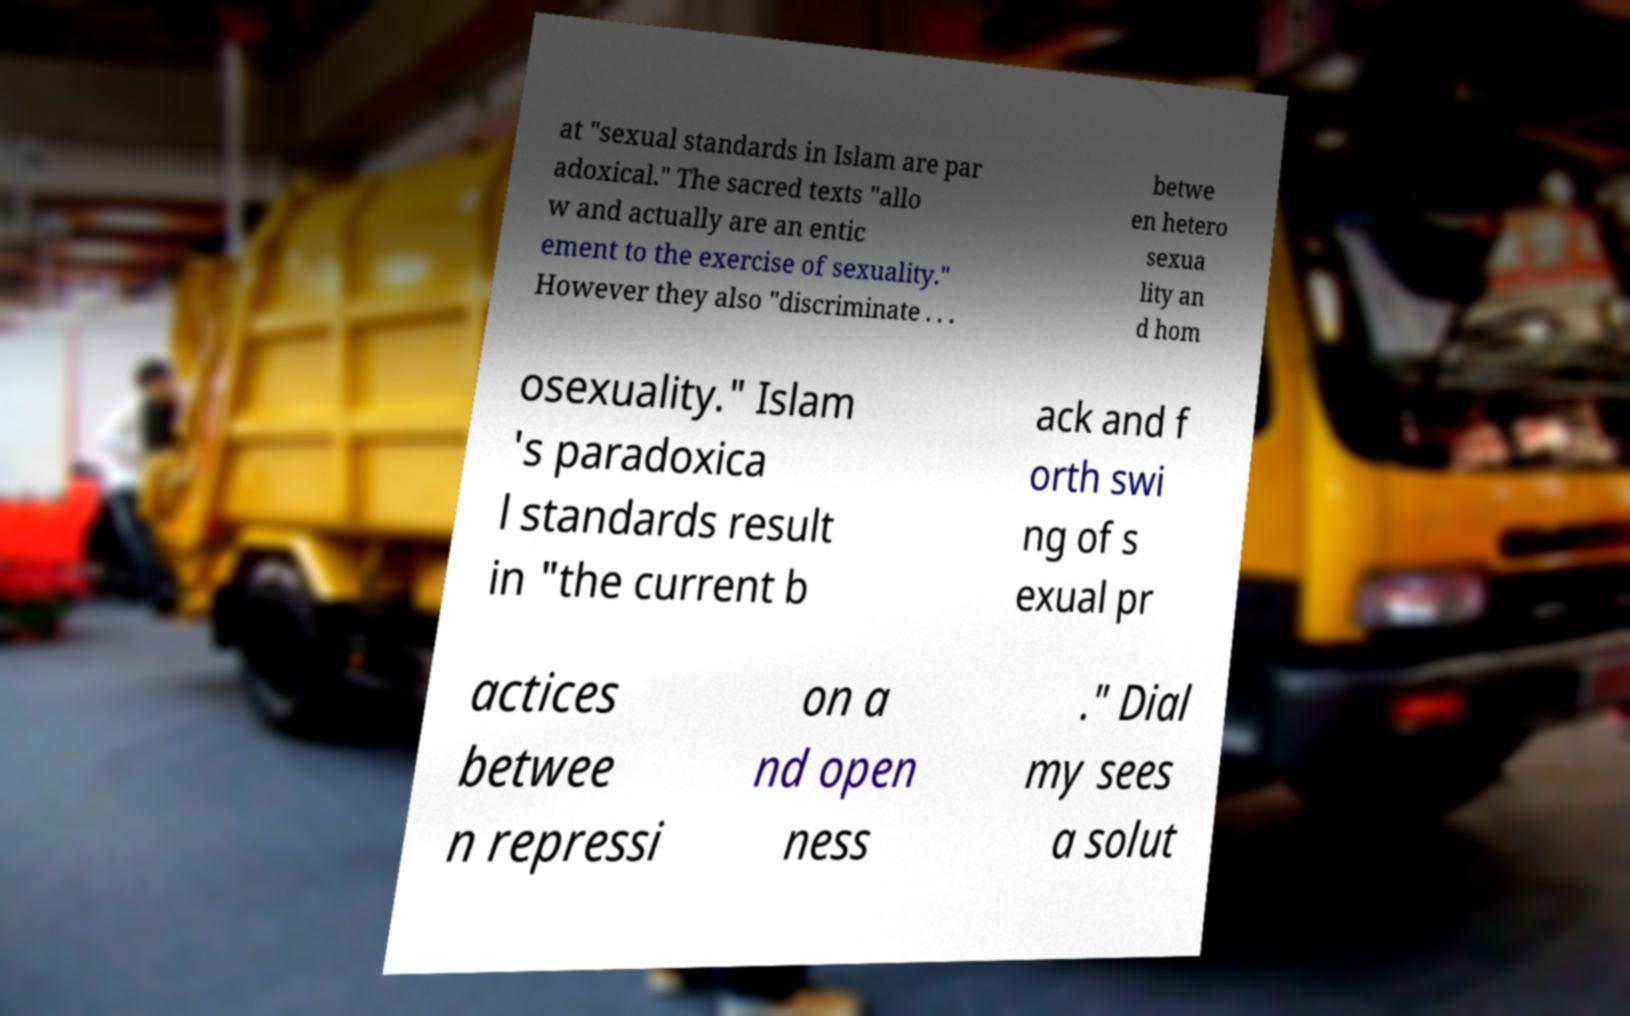Could you extract and type out the text from this image? at "sexual standards in Islam are par adoxical." The sacred texts "allo w and actually are an entic ement to the exercise of sexuality." However they also "discriminate . . . betwe en hetero sexua lity an d hom osexuality." Islam 's paradoxica l standards result in "the current b ack and f orth swi ng of s exual pr actices betwee n repressi on a nd open ness ." Dial my sees a solut 